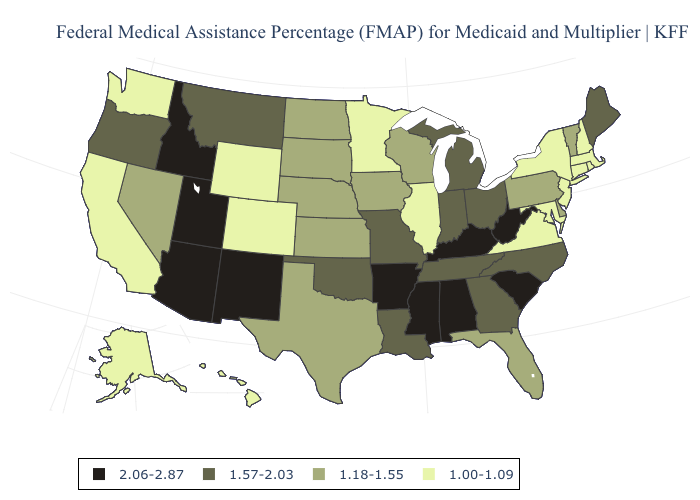Does Ohio have a lower value than Idaho?
Quick response, please. Yes. Name the states that have a value in the range 2.06-2.87?
Quick response, please. Alabama, Arizona, Arkansas, Idaho, Kentucky, Mississippi, New Mexico, South Carolina, Utah, West Virginia. Does Minnesota have the same value as New Hampshire?
Concise answer only. Yes. Does Wisconsin have the highest value in the USA?
Give a very brief answer. No. Does West Virginia have the highest value in the South?
Short answer required. Yes. Name the states that have a value in the range 2.06-2.87?
Give a very brief answer. Alabama, Arizona, Arkansas, Idaho, Kentucky, Mississippi, New Mexico, South Carolina, Utah, West Virginia. Name the states that have a value in the range 1.18-1.55?
Answer briefly. Delaware, Florida, Iowa, Kansas, Nebraska, Nevada, North Dakota, Pennsylvania, South Dakota, Texas, Vermont, Wisconsin. What is the highest value in the MidWest ?
Keep it brief. 1.57-2.03. Does Nevada have the same value as Montana?
Write a very short answer. No. Does the first symbol in the legend represent the smallest category?
Be succinct. No. What is the value of Wisconsin?
Give a very brief answer. 1.18-1.55. What is the lowest value in the USA?
Quick response, please. 1.00-1.09. Name the states that have a value in the range 2.06-2.87?
Quick response, please. Alabama, Arizona, Arkansas, Idaho, Kentucky, Mississippi, New Mexico, South Carolina, Utah, West Virginia. Name the states that have a value in the range 1.57-2.03?
Quick response, please. Georgia, Indiana, Louisiana, Maine, Michigan, Missouri, Montana, North Carolina, Ohio, Oklahoma, Oregon, Tennessee. What is the value of Alabama?
Give a very brief answer. 2.06-2.87. 